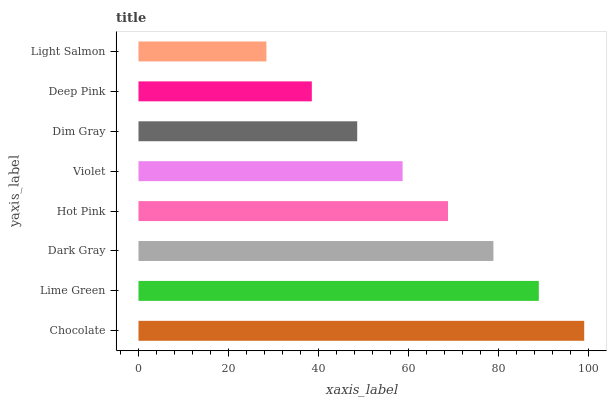Is Light Salmon the minimum?
Answer yes or no. Yes. Is Chocolate the maximum?
Answer yes or no. Yes. Is Lime Green the minimum?
Answer yes or no. No. Is Lime Green the maximum?
Answer yes or no. No. Is Chocolate greater than Lime Green?
Answer yes or no. Yes. Is Lime Green less than Chocolate?
Answer yes or no. Yes. Is Lime Green greater than Chocolate?
Answer yes or no. No. Is Chocolate less than Lime Green?
Answer yes or no. No. Is Hot Pink the high median?
Answer yes or no. Yes. Is Violet the low median?
Answer yes or no. Yes. Is Violet the high median?
Answer yes or no. No. Is Hot Pink the low median?
Answer yes or no. No. 